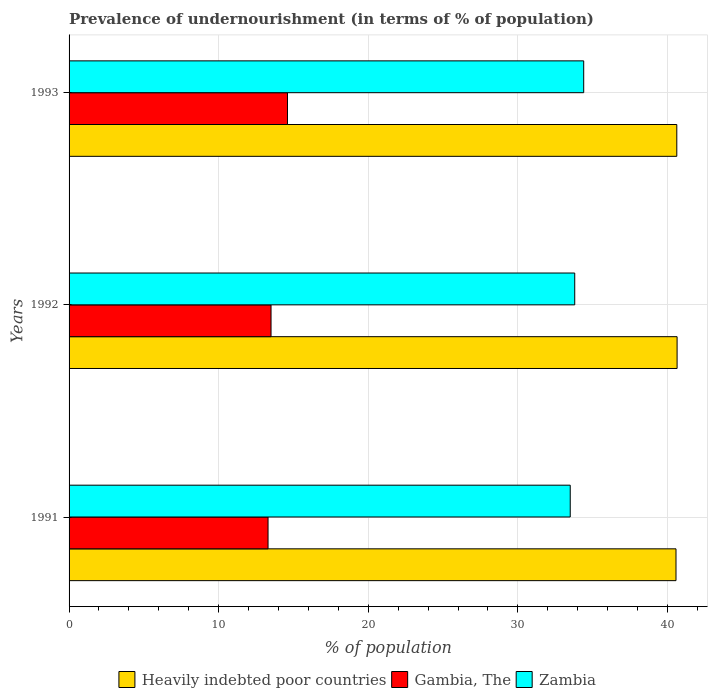How many groups of bars are there?
Make the answer very short. 3. Are the number of bars per tick equal to the number of legend labels?
Your answer should be compact. Yes. Are the number of bars on each tick of the Y-axis equal?
Offer a terse response. Yes. What is the percentage of undernourished population in Zambia in 1991?
Ensure brevity in your answer.  33.5. Across all years, what is the maximum percentage of undernourished population in Gambia, The?
Give a very brief answer. 14.6. In which year was the percentage of undernourished population in Gambia, The maximum?
Offer a very short reply. 1993. What is the total percentage of undernourished population in Zambia in the graph?
Keep it short and to the point. 101.7. What is the difference between the percentage of undernourished population in Gambia, The in 1992 and that in 1993?
Provide a short and direct response. -1.1. What is the difference between the percentage of undernourished population in Gambia, The in 1992 and the percentage of undernourished population in Zambia in 1993?
Offer a very short reply. -20.9. What is the average percentage of undernourished population in Heavily indebted poor countries per year?
Keep it short and to the point. 40.61. In the year 1992, what is the difference between the percentage of undernourished population in Gambia, The and percentage of undernourished population in Zambia?
Your answer should be very brief. -20.3. In how many years, is the percentage of undernourished population in Heavily indebted poor countries greater than 14 %?
Offer a terse response. 3. What is the ratio of the percentage of undernourished population in Gambia, The in 1991 to that in 1992?
Provide a short and direct response. 0.99. Is the percentage of undernourished population in Heavily indebted poor countries in 1992 less than that in 1993?
Give a very brief answer. No. Is the difference between the percentage of undernourished population in Gambia, The in 1991 and 1992 greater than the difference between the percentage of undernourished population in Zambia in 1991 and 1992?
Your response must be concise. Yes. What is the difference between the highest and the second highest percentage of undernourished population in Gambia, The?
Your answer should be compact. 1.1. What is the difference between the highest and the lowest percentage of undernourished population in Heavily indebted poor countries?
Your response must be concise. 0.07. What does the 1st bar from the top in 1991 represents?
Offer a very short reply. Zambia. What does the 1st bar from the bottom in 1992 represents?
Provide a short and direct response. Heavily indebted poor countries. Is it the case that in every year, the sum of the percentage of undernourished population in Zambia and percentage of undernourished population in Heavily indebted poor countries is greater than the percentage of undernourished population in Gambia, The?
Ensure brevity in your answer.  Yes. Are all the bars in the graph horizontal?
Give a very brief answer. Yes. How many years are there in the graph?
Your response must be concise. 3. Are the values on the major ticks of X-axis written in scientific E-notation?
Keep it short and to the point. No. How are the legend labels stacked?
Give a very brief answer. Horizontal. What is the title of the graph?
Your answer should be very brief. Prevalence of undernourishment (in terms of % of population). Does "Maldives" appear as one of the legend labels in the graph?
Offer a terse response. No. What is the label or title of the X-axis?
Provide a succinct answer. % of population. What is the % of population in Heavily indebted poor countries in 1991?
Make the answer very short. 40.57. What is the % of population of Gambia, The in 1991?
Offer a terse response. 13.3. What is the % of population of Zambia in 1991?
Your answer should be very brief. 33.5. What is the % of population of Heavily indebted poor countries in 1992?
Give a very brief answer. 40.64. What is the % of population in Gambia, The in 1992?
Provide a short and direct response. 13.5. What is the % of population in Zambia in 1992?
Offer a very short reply. 33.8. What is the % of population in Heavily indebted poor countries in 1993?
Offer a terse response. 40.62. What is the % of population of Gambia, The in 1993?
Make the answer very short. 14.6. What is the % of population in Zambia in 1993?
Give a very brief answer. 34.4. Across all years, what is the maximum % of population in Heavily indebted poor countries?
Your answer should be compact. 40.64. Across all years, what is the maximum % of population in Gambia, The?
Offer a very short reply. 14.6. Across all years, what is the maximum % of population of Zambia?
Offer a terse response. 34.4. Across all years, what is the minimum % of population of Heavily indebted poor countries?
Your answer should be very brief. 40.57. Across all years, what is the minimum % of population in Gambia, The?
Provide a short and direct response. 13.3. Across all years, what is the minimum % of population in Zambia?
Your response must be concise. 33.5. What is the total % of population in Heavily indebted poor countries in the graph?
Give a very brief answer. 121.83. What is the total % of population of Gambia, The in the graph?
Keep it short and to the point. 41.4. What is the total % of population of Zambia in the graph?
Your response must be concise. 101.7. What is the difference between the % of population in Heavily indebted poor countries in 1991 and that in 1992?
Ensure brevity in your answer.  -0.07. What is the difference between the % of population of Zambia in 1991 and that in 1992?
Offer a terse response. -0.3. What is the difference between the % of population of Heavily indebted poor countries in 1991 and that in 1993?
Offer a very short reply. -0.05. What is the difference between the % of population of Gambia, The in 1991 and that in 1993?
Provide a succinct answer. -1.3. What is the difference between the % of population of Heavily indebted poor countries in 1992 and that in 1993?
Your response must be concise. 0.02. What is the difference between the % of population in Gambia, The in 1992 and that in 1993?
Make the answer very short. -1.1. What is the difference between the % of population of Zambia in 1992 and that in 1993?
Make the answer very short. -0.6. What is the difference between the % of population of Heavily indebted poor countries in 1991 and the % of population of Gambia, The in 1992?
Give a very brief answer. 27.07. What is the difference between the % of population of Heavily indebted poor countries in 1991 and the % of population of Zambia in 1992?
Give a very brief answer. 6.77. What is the difference between the % of population in Gambia, The in 1991 and the % of population in Zambia in 1992?
Provide a short and direct response. -20.5. What is the difference between the % of population of Heavily indebted poor countries in 1991 and the % of population of Gambia, The in 1993?
Provide a succinct answer. 25.97. What is the difference between the % of population of Heavily indebted poor countries in 1991 and the % of population of Zambia in 1993?
Offer a very short reply. 6.17. What is the difference between the % of population in Gambia, The in 1991 and the % of population in Zambia in 1993?
Your answer should be very brief. -21.1. What is the difference between the % of population of Heavily indebted poor countries in 1992 and the % of population of Gambia, The in 1993?
Offer a very short reply. 26.04. What is the difference between the % of population of Heavily indebted poor countries in 1992 and the % of population of Zambia in 1993?
Provide a short and direct response. 6.24. What is the difference between the % of population of Gambia, The in 1992 and the % of population of Zambia in 1993?
Provide a short and direct response. -20.9. What is the average % of population of Heavily indebted poor countries per year?
Ensure brevity in your answer.  40.61. What is the average % of population of Zambia per year?
Provide a short and direct response. 33.9. In the year 1991, what is the difference between the % of population of Heavily indebted poor countries and % of population of Gambia, The?
Provide a succinct answer. 27.27. In the year 1991, what is the difference between the % of population in Heavily indebted poor countries and % of population in Zambia?
Your response must be concise. 7.07. In the year 1991, what is the difference between the % of population in Gambia, The and % of population in Zambia?
Make the answer very short. -20.2. In the year 1992, what is the difference between the % of population of Heavily indebted poor countries and % of population of Gambia, The?
Offer a very short reply. 27.14. In the year 1992, what is the difference between the % of population in Heavily indebted poor countries and % of population in Zambia?
Keep it short and to the point. 6.84. In the year 1992, what is the difference between the % of population of Gambia, The and % of population of Zambia?
Keep it short and to the point. -20.3. In the year 1993, what is the difference between the % of population of Heavily indebted poor countries and % of population of Gambia, The?
Keep it short and to the point. 26.02. In the year 1993, what is the difference between the % of population in Heavily indebted poor countries and % of population in Zambia?
Your answer should be very brief. 6.22. In the year 1993, what is the difference between the % of population in Gambia, The and % of population in Zambia?
Offer a terse response. -19.8. What is the ratio of the % of population of Gambia, The in 1991 to that in 1992?
Provide a succinct answer. 0.99. What is the ratio of the % of population of Zambia in 1991 to that in 1992?
Your answer should be very brief. 0.99. What is the ratio of the % of population of Heavily indebted poor countries in 1991 to that in 1993?
Make the answer very short. 1. What is the ratio of the % of population in Gambia, The in 1991 to that in 1993?
Keep it short and to the point. 0.91. What is the ratio of the % of population in Zambia in 1991 to that in 1993?
Offer a very short reply. 0.97. What is the ratio of the % of population in Gambia, The in 1992 to that in 1993?
Ensure brevity in your answer.  0.92. What is the ratio of the % of population in Zambia in 1992 to that in 1993?
Keep it short and to the point. 0.98. What is the difference between the highest and the second highest % of population in Heavily indebted poor countries?
Provide a short and direct response. 0.02. What is the difference between the highest and the second highest % of population of Gambia, The?
Provide a succinct answer. 1.1. What is the difference between the highest and the lowest % of population of Heavily indebted poor countries?
Keep it short and to the point. 0.07. What is the difference between the highest and the lowest % of population in Gambia, The?
Make the answer very short. 1.3. What is the difference between the highest and the lowest % of population of Zambia?
Offer a terse response. 0.9. 